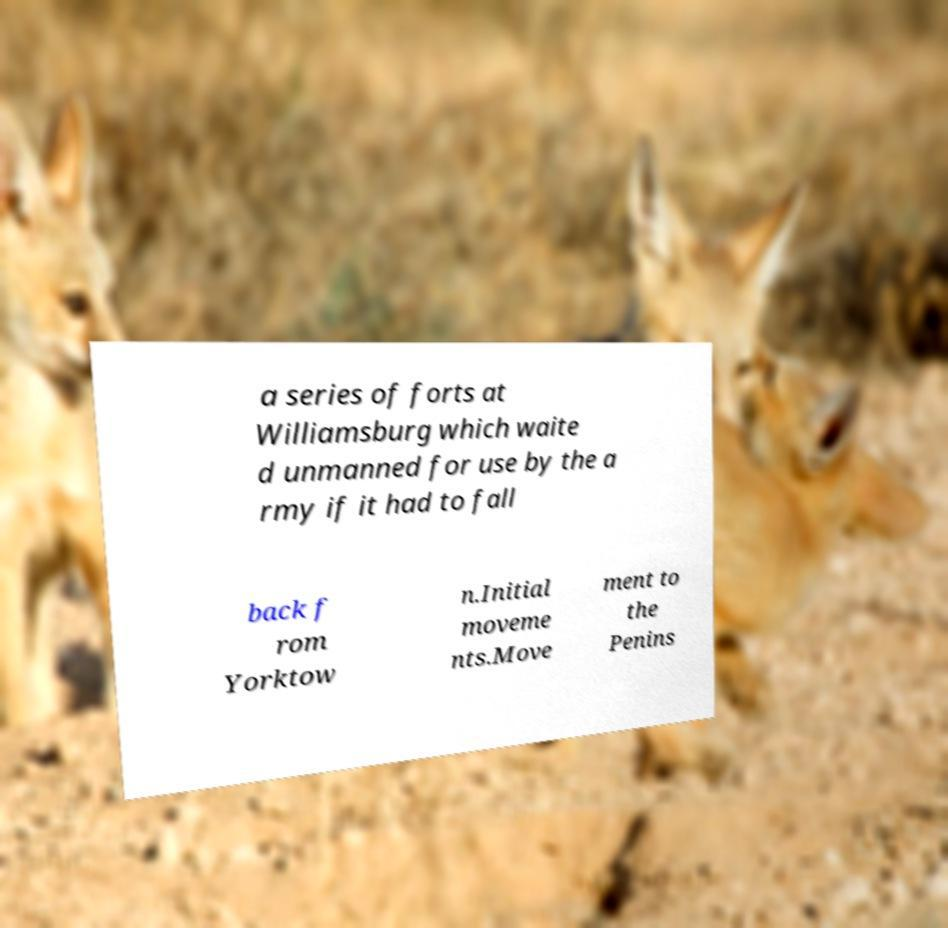I need the written content from this picture converted into text. Can you do that? a series of forts at Williamsburg which waite d unmanned for use by the a rmy if it had to fall back f rom Yorktow n.Initial moveme nts.Move ment to the Penins 